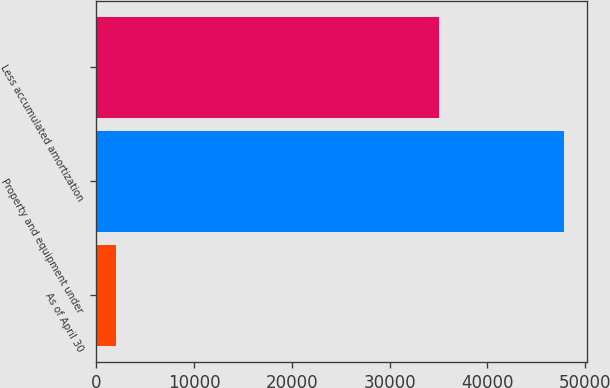Convert chart to OTSL. <chart><loc_0><loc_0><loc_500><loc_500><bar_chart><fcel>As of April 30<fcel>Property and equipment under<fcel>Less accumulated amortization<nl><fcel>2011<fcel>47842<fcel>35056<nl></chart> 